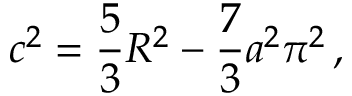Convert formula to latex. <formula><loc_0><loc_0><loc_500><loc_500>c ^ { 2 } = \frac { 5 } { 3 } R ^ { 2 } - \frac { 7 } { 3 } a ^ { 2 } \pi ^ { 2 } \, ,</formula> 